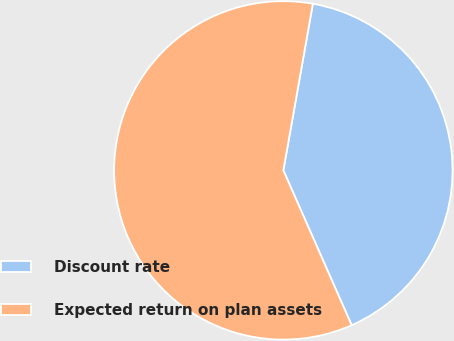Convert chart to OTSL. <chart><loc_0><loc_0><loc_500><loc_500><pie_chart><fcel>Discount rate<fcel>Expected return on plan assets<nl><fcel>40.6%<fcel>59.4%<nl></chart> 